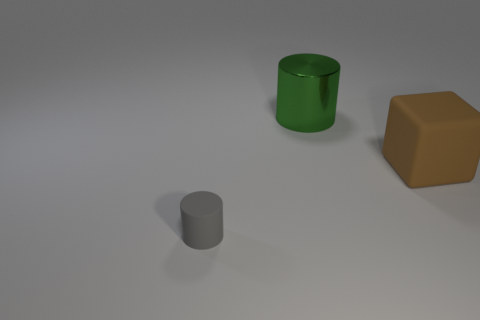Is there any other thing that has the same size as the gray matte thing?
Ensure brevity in your answer.  No. There is a matte thing that is left of the rubber object that is behind the tiny gray thing; what is its size?
Give a very brief answer. Small. Are there any big green spheres that have the same material as the green cylinder?
Make the answer very short. No. There is a green thing that is the same size as the rubber cube; what is its material?
Provide a succinct answer. Metal. There is a cylinder that is behind the gray matte cylinder; is there a big brown block that is left of it?
Provide a succinct answer. No. Do the rubber thing behind the tiny rubber cylinder and the rubber thing to the left of the big green cylinder have the same shape?
Provide a short and direct response. No. Does the cylinder that is left of the green shiny thing have the same material as the object that is to the right of the big metal thing?
Provide a short and direct response. Yes. There is a large thing on the left side of the rubber object that is behind the small cylinder; what is its material?
Give a very brief answer. Metal. What shape is the thing in front of the object that is on the right side of the cylinder right of the small gray thing?
Your response must be concise. Cylinder. What is the material of the tiny gray object that is the same shape as the green metallic object?
Your response must be concise. Rubber. 